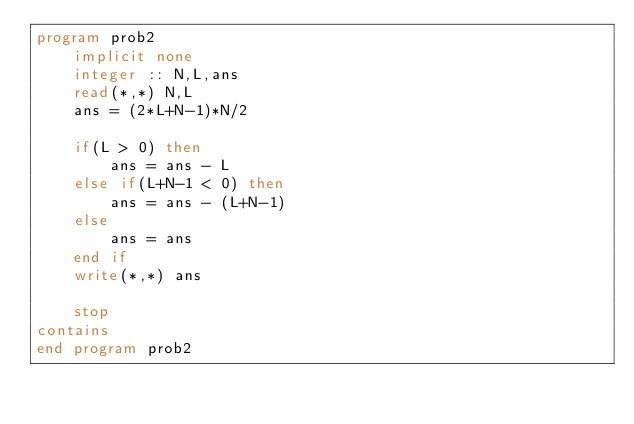Convert code to text. <code><loc_0><loc_0><loc_500><loc_500><_FORTRAN_>program prob2
    implicit none
    integer :: N,L,ans
    read(*,*) N,L
    ans = (2*L+N-1)*N/2

    if(L > 0) then
        ans = ans - L
    else if(L+N-1 < 0) then
        ans = ans - (L+N-1)
    else
        ans = ans
    end if
    write(*,*) ans

    stop
contains
end program prob2</code> 